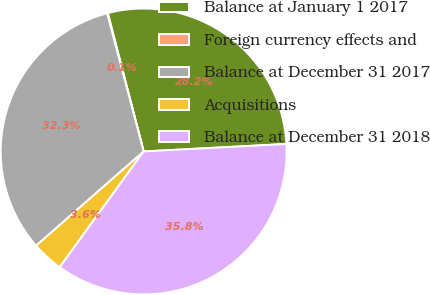Convert chart to OTSL. <chart><loc_0><loc_0><loc_500><loc_500><pie_chart><fcel>Balance at January 1 2017<fcel>Foreign currency effects and<fcel>Balance at December 31 2017<fcel>Acquisitions<fcel>Balance at December 31 2018<nl><fcel>28.2%<fcel>0.08%<fcel>32.34%<fcel>3.56%<fcel>35.82%<nl></chart> 